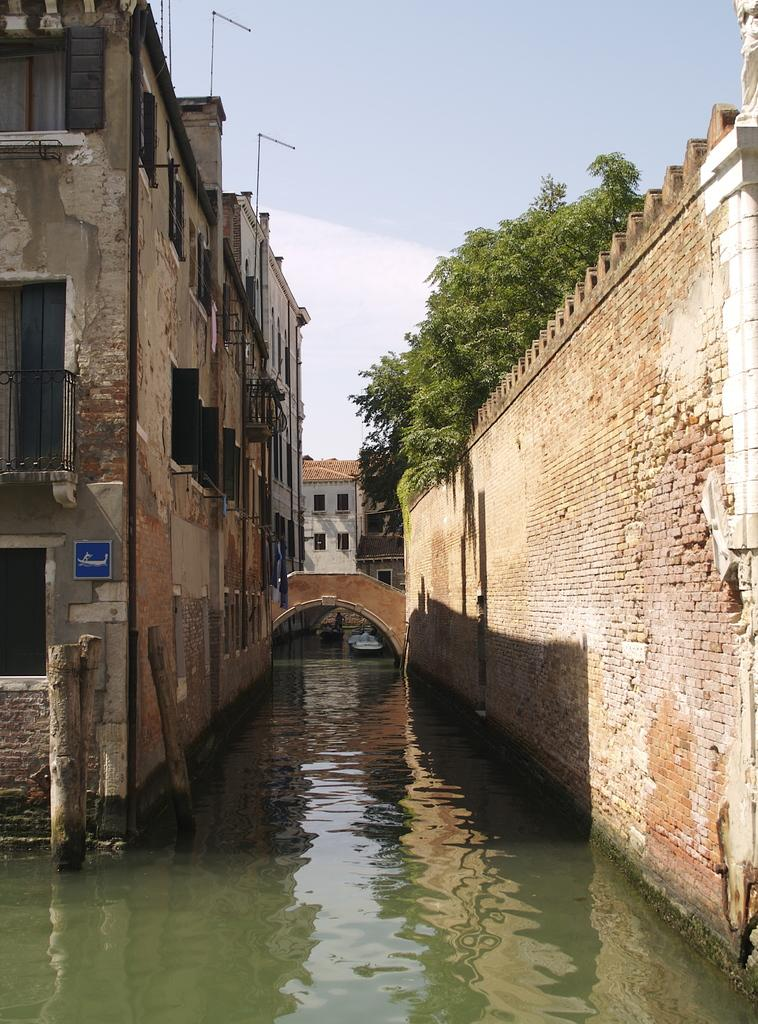What type of structures can be seen in the image? There are buildings in the image. What other natural elements are present in the image? There are trees and water visible in the image. How would you describe the sky in the image? The sky is blue and cloudy. What type of chin can be seen on the trees in the image? There are no chins present in the image, as chins are a human facial feature and not applicable to trees. 